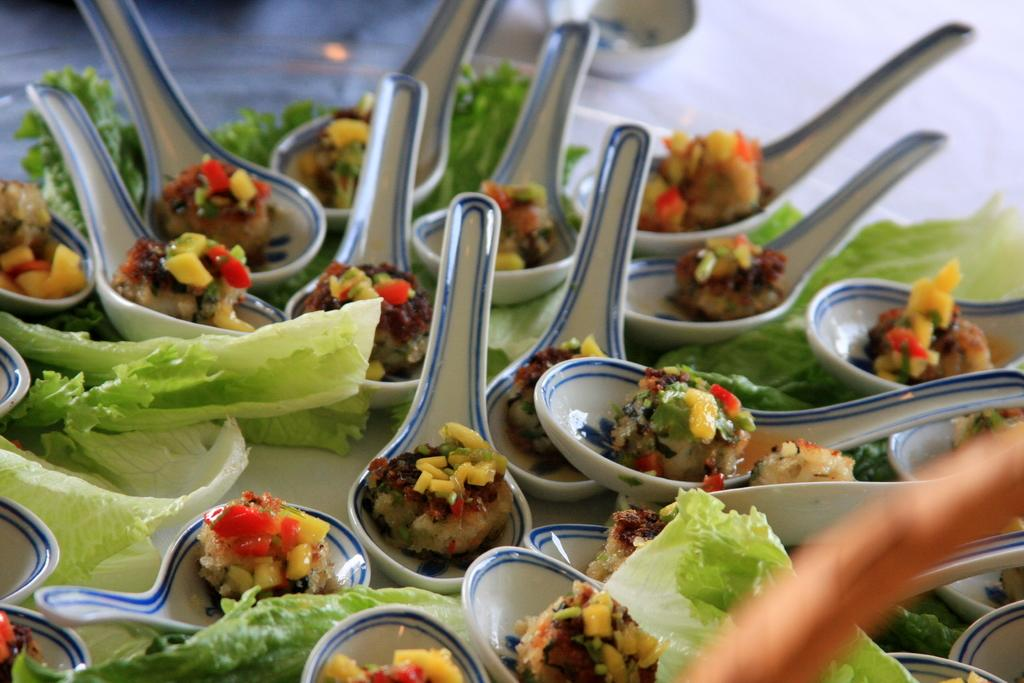What types of food items can be seen in the image? The image contains food items in green, yellow, red, and brown colors. What colors are the spoons in the image? The spoons in the image are white and blue. Is the girl in the image wearing a red hat? There is no girl present in the image, so it is not possible to determine if she is wearing a red hat. 